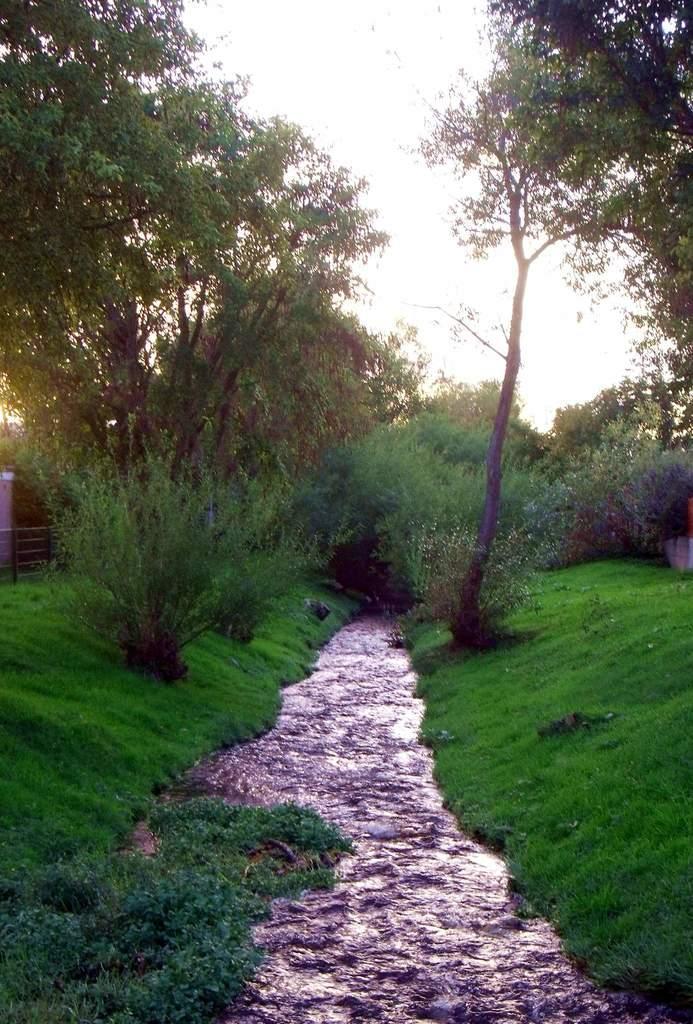Describe this image in one or two sentences. In this image in the center there is water. In the background there is grass on the ground and there are trees, on the left side there is a fence and there is a wall. At the top there is sky. 